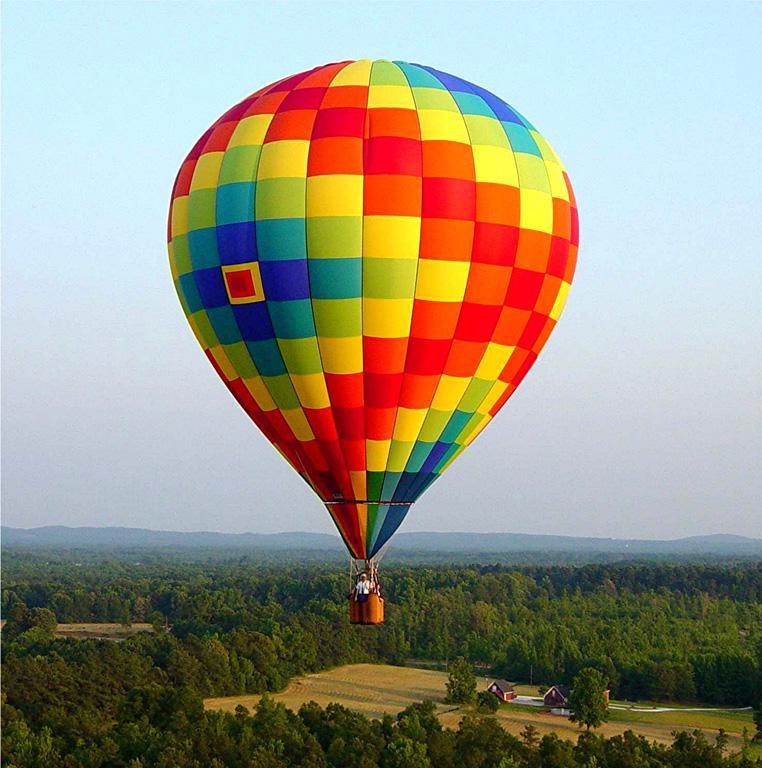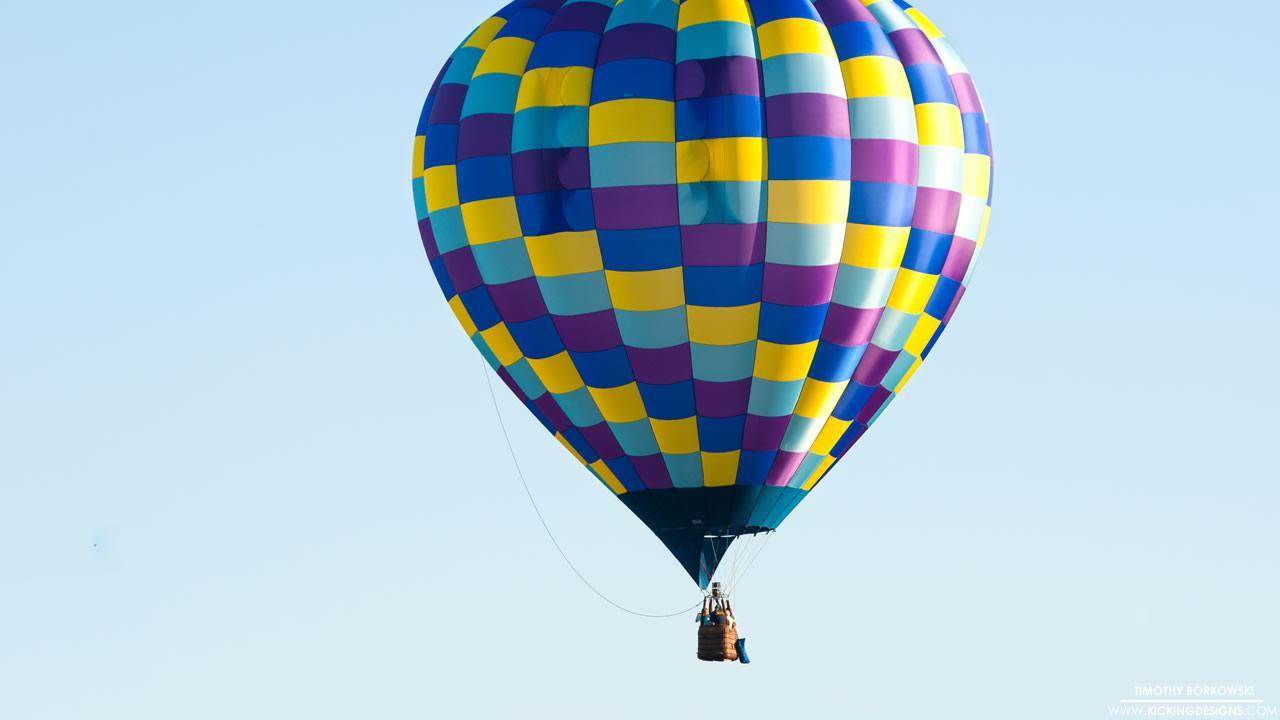The first image is the image on the left, the second image is the image on the right. For the images shown, is this caption "There are no more than two hot air balloons." true? Answer yes or no. Yes. The first image is the image on the left, the second image is the image on the right. Considering the images on both sides, is "One of the images has at least one hot air balloon with characters or pictures on it." valid? Answer yes or no. No. 